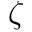<formula> <loc_0><loc_0><loc_500><loc_500>\zeta</formula> 